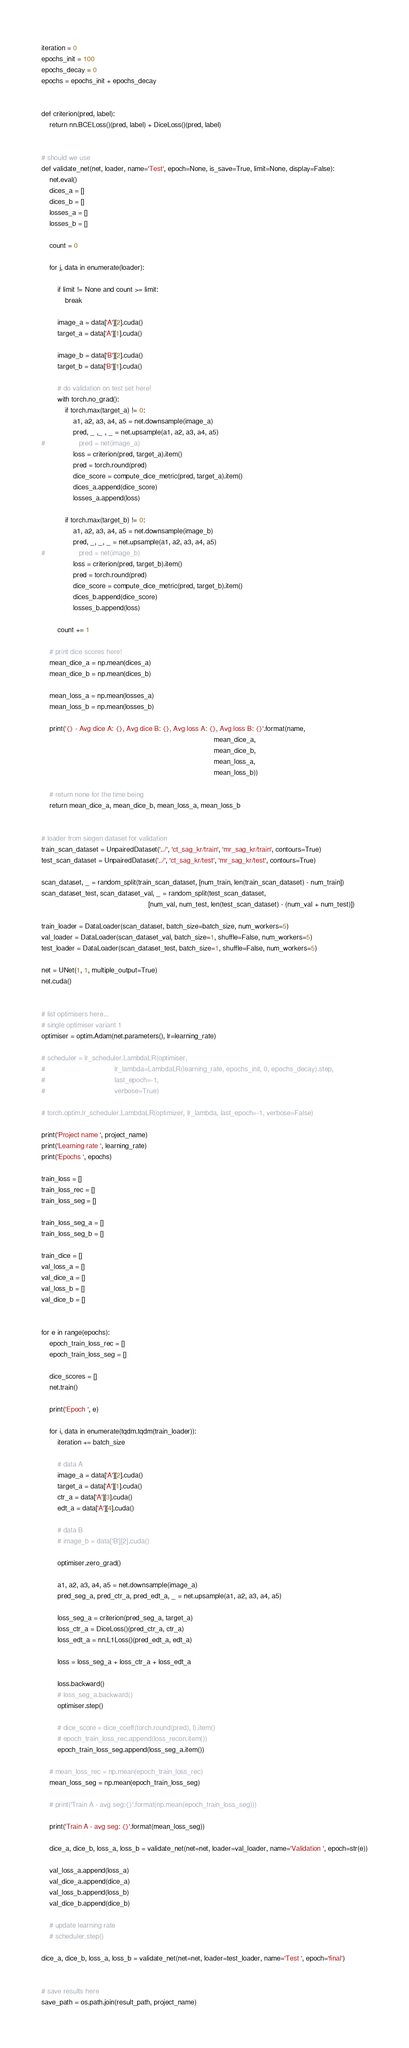<code> <loc_0><loc_0><loc_500><loc_500><_Python_>iteration = 0
epochs_init = 100
epochs_decay = 0
epochs = epochs_init + epochs_decay


def criterion(pred, label):
    return nn.BCELoss()(pred, label) + DiceLoss()(pred, label)


# should we use 
def validate_net(net, loader, name='Test', epoch=None, is_save=True, limit=None, display=False):
    net.eval()
    dices_a = []
    dices_b = []
    losses_a = []
    losses_b = []
    
    count = 0
    
    for j, data in enumerate(loader):
        
        if limit != None and count >= limit:
            break
            
        image_a = data['A'][2].cuda()
        target_a = data['A'][1].cuda()
        
        image_b = data['B'][2].cuda()
        target_b = data['B'][1].cuda()
        
        # do validation on test set here!
        with torch.no_grad():
            if torch.max(target_a) != 0:
                a1, a2, a3, a4, a5 = net.downsample(image_a)      
                pred, _ ,_ , _ = net.upsample(a1, a2, a3, a4, a5)
#                 pred = net(image_a)
                loss = criterion(pred, target_a).item()
                pred = torch.round(pred)
                dice_score = compute_dice_metric(pred, target_a).item()
                dices_a.append(dice_score)
                losses_a.append(loss)
            
            if torch.max(target_b) != 0:
                a1, a2, a3, a4, a5 = net.downsample(image_b)      
                pred, _, _, _ = net.upsample(a1, a2, a3, a4, a5)
#                 pred = net(image_b)
                loss = criterion(pred, target_b).item()
                pred = torch.round(pred)
                dice_score = compute_dice_metric(pred, target_b).item()
                dices_b.append(dice_score)
                losses_b.append(loss)
                        
        count += 1
    
    # print dice scores here!
    mean_dice_a = np.mean(dices_a)
    mean_dice_b = np.mean(dices_b)
    
    mean_loss_a = np.mean(losses_a)
    mean_loss_b = np.mean(losses_b)
    
    print('{} - Avg dice A: {}, Avg dice B: {}, Avg loss A: {}, Avg loss B: {}'.format(name, 
                                                                                       mean_dice_a, 
                                                                                       mean_dice_b, 
                                                                                       mean_loss_a, 
                                                                                       mean_loss_b))
            
    # return none for the time being
    return mean_dice_a, mean_dice_b, mean_loss_a, mean_loss_b


# loader from siegen dataset for validation
train_scan_dataset = UnpairedDataset('../', 'ct_sag_kr/train', 'mr_sag_kr/train', contours=True)
test_scan_dataset = UnpairedDataset('../', 'ct_sag_kr/test', 'mr_sag_kr/test', contours=True)

scan_dataset, _ = random_split(train_scan_dataset, [num_train, len(train_scan_dataset) - num_train])
scan_dataset_test, scan_dataset_val, _ = random_split(test_scan_dataset, 
                                                      [num_val, num_test, len(test_scan_dataset) - (num_val + num_test)])

train_loader = DataLoader(scan_dataset, batch_size=batch_size, num_workers=5)
val_loader = DataLoader(scan_dataset_val, batch_size=1, shuffle=False, num_workers=5)
test_loader = DataLoader(scan_dataset_test, batch_size=1, shuffle=False, num_workers=5)

net = UNet(1, 1, multiple_output=True)
net.cuda()


# list optimisers here...
# single optimiser variant 1
optimiser = optim.Adam(net.parameters(), lr=learning_rate)

# scheduler = lr_scheduler.LambdaLR(optimiser, 
#                                   lr_lambda=LambdaLR(learning_rate, epochs_init, 0, epochs_decay).step,
#                                   last_epoch=-1,
#                                   verbose=True)

# torch.optim.lr_scheduler.LambdaLR(optimizer, lr_lambda, last_epoch=-1, verbose=False)

print('Project name ', project_name)
print('Learning rate ', learning_rate)
print('Epochs ', epochs)

train_loss = []
train_loss_rec = []
train_loss_seg = []

train_loss_seg_a = []
train_loss_seg_b = []

train_dice = []
val_loss_a = []
val_dice_a = []
val_loss_b = []
val_dice_b = []


for e in range(epochs):
    epoch_train_loss_rec = []
    epoch_train_loss_seg = []
    
    dice_scores = []
    net.train() 
    
    print('Epoch ', e)
    
    for i, data in enumerate(tqdm.tqdm(train_loader)):
        iteration += batch_size
        
        # data A
        image_a = data['A'][2].cuda()
        target_a = data['A'][1].cuda()
        ctr_a = data['A'][3].cuda()
        edt_a = data['A'][4].cuda()
        
        # data B
        # image_b = data['B'][2].cuda()

        optimiser.zero_grad()
        
        a1, a2, a3, a4, a5 = net.downsample(image_a)        
        pred_seg_a, pred_ctr_a, pred_edt_a, _ = net.upsample(a1, a2, a3, a4, a5)
        
        loss_seg_a = criterion(pred_seg_a, target_a)
        loss_ctr_a = DiceLoss()(pred_ctr_a, ctr_a)
        loss_edt_a = nn.L1Loss()(pred_edt_a, edt_a)
        
        loss = loss_seg_a + loss_ctr_a + loss_edt_a
        
        loss.backward()
        # loss_seg_a.backward()        
        optimiser.step()
                    
        # dice_score = dice_coeff(torch.round(pred), l).item()
        # epoch_train_loss_rec.append(loss_recon.item())
        epoch_train_loss_seg.append(loss_seg_a.item())
        
    # mean_loss_rec = np.mean(epoch_train_loss_rec)
    mean_loss_seg = np.mean(epoch_train_loss_seg)
    
    # print('Train A - avg seg:{}'.format(np.mean(epoch_train_loss_seg)))
    
    print('Train A - avg seg: {}'.format(mean_loss_seg))

    dice_a, dice_b, loss_a, loss_b = validate_net(net=net, loader=val_loader, name='Validation ', epoch=str(e))
    
    val_loss_a.append(loss_a)
    val_dice_a.append(dice_a)
    val_loss_b.append(loss_b)
    val_dice_b.append(dice_b)
    
    # update learning rate
    # scheduler.step()
    
dice_a, dice_b, loss_a, loss_b = validate_net(net=net, loader=test_loader, name='Test ', epoch='final')


# save results here
save_path = os.path.join(result_path, project_name)
</code> 